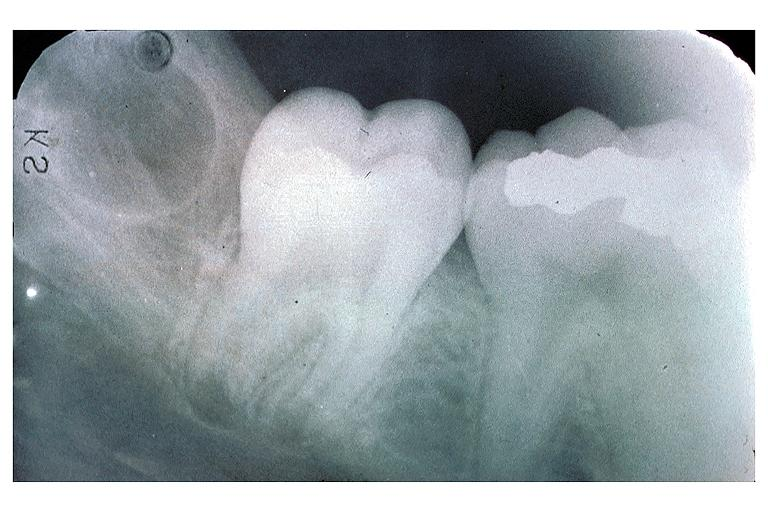does this image show developing 3rd molar?
Answer the question using a single word or phrase. Yes 